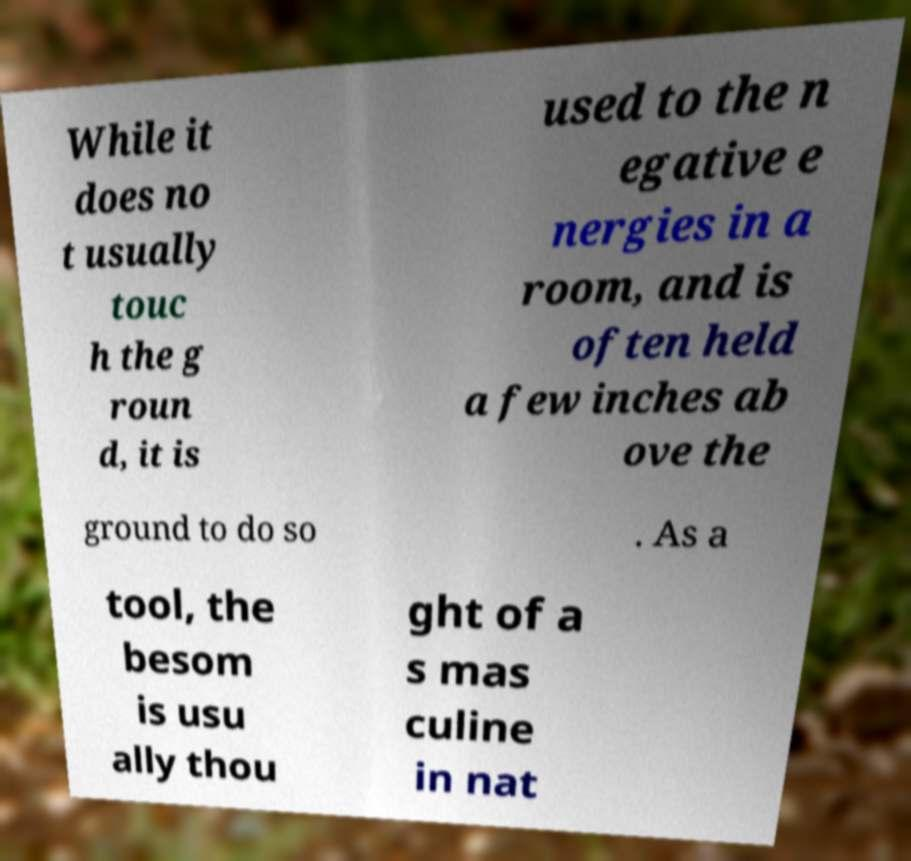I need the written content from this picture converted into text. Can you do that? While it does no t usually touc h the g roun d, it is used to the n egative e nergies in a room, and is often held a few inches ab ove the ground to do so . As a tool, the besom is usu ally thou ght of a s mas culine in nat 